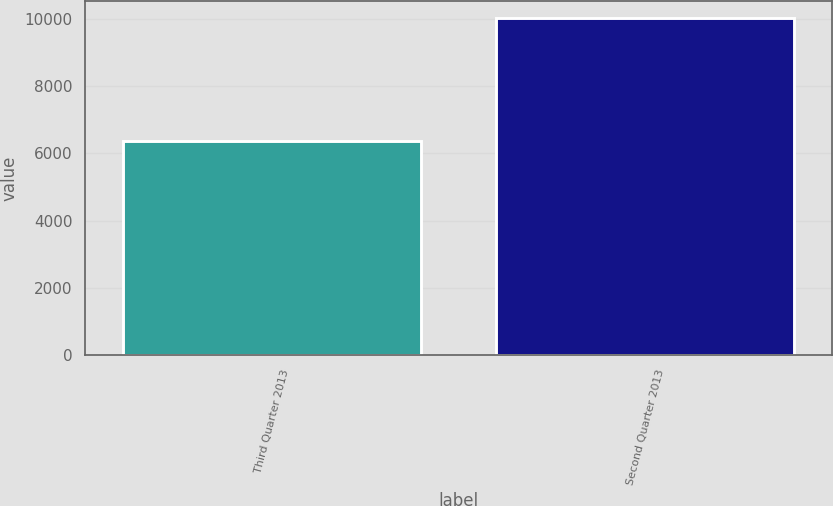Convert chart to OTSL. <chart><loc_0><loc_0><loc_500><loc_500><bar_chart><fcel>Third Quarter 2013<fcel>Second Quarter 2013<nl><fcel>6376<fcel>10046<nl></chart> 